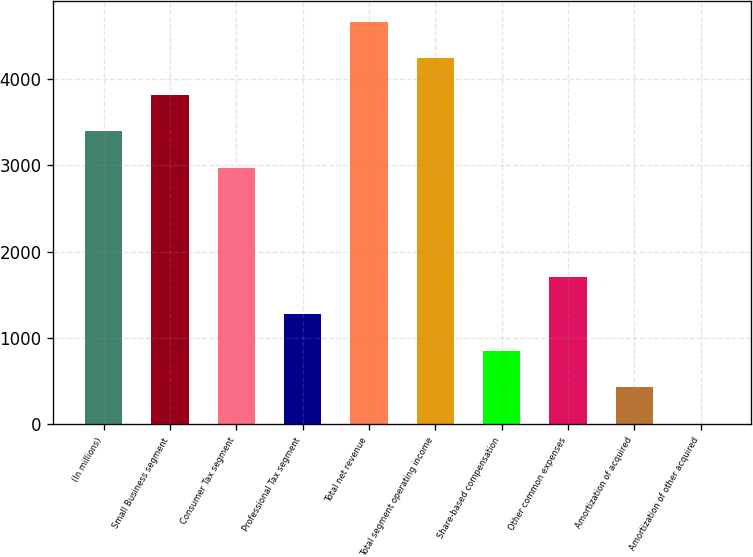<chart> <loc_0><loc_0><loc_500><loc_500><bar_chart><fcel>(In millions)<fcel>Small Business segment<fcel>Consumer Tax segment<fcel>Professional Tax segment<fcel>Total net revenue<fcel>Total segment operating income<fcel>Share-based compensation<fcel>Other common expenses<fcel>Amortization of acquired<fcel>Amortization of other acquired<nl><fcel>3395.8<fcel>3819.4<fcel>2972.2<fcel>1277.8<fcel>4666.6<fcel>4243<fcel>854.2<fcel>1701.4<fcel>430.6<fcel>7<nl></chart> 